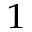Convert formula to latex. <formula><loc_0><loc_0><loc_500><loc_500>^ { 1 }</formula> 